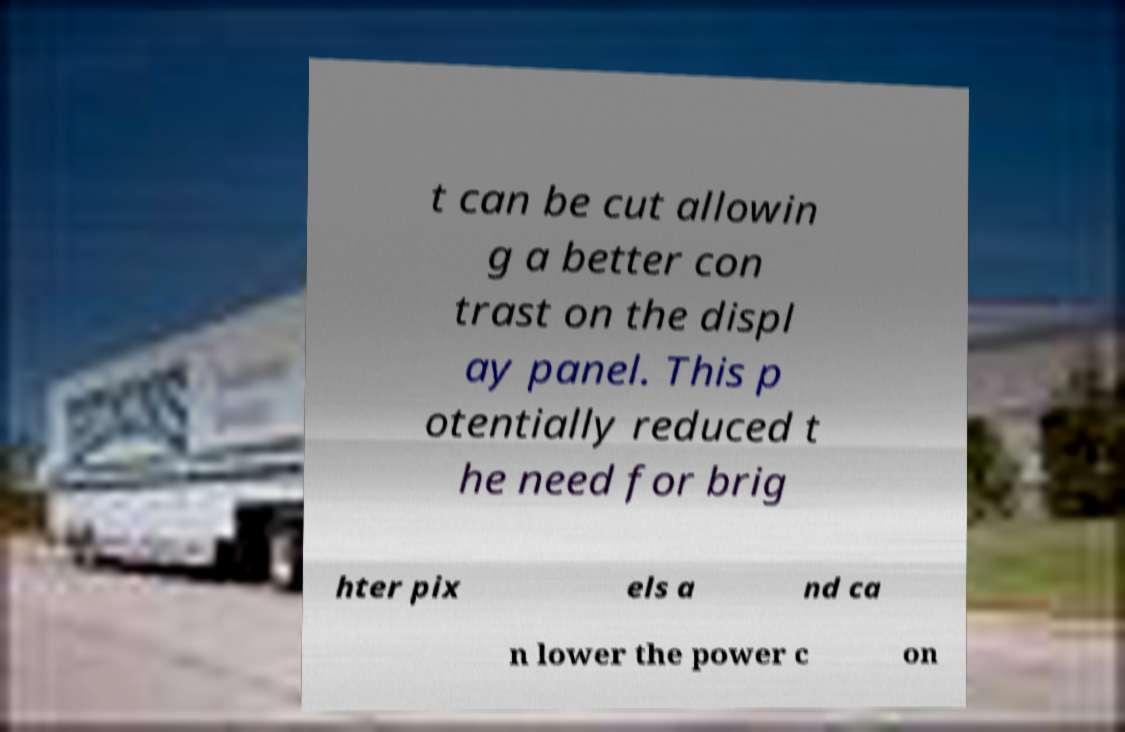For documentation purposes, I need the text within this image transcribed. Could you provide that? t can be cut allowin g a better con trast on the displ ay panel. This p otentially reduced t he need for brig hter pix els a nd ca n lower the power c on 